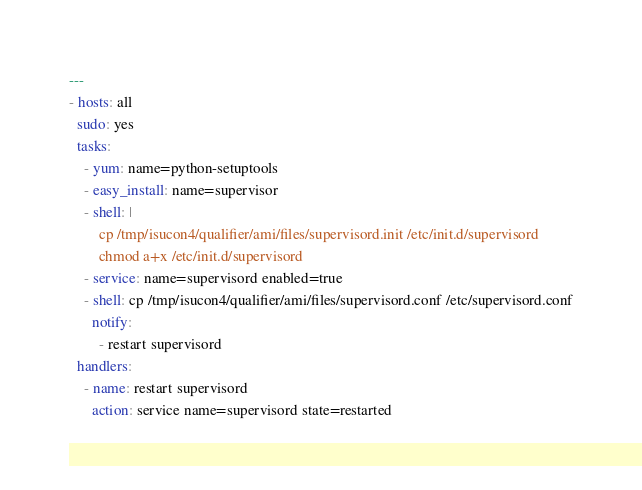Convert code to text. <code><loc_0><loc_0><loc_500><loc_500><_YAML_>---
- hosts: all
  sudo: yes
  tasks:
    - yum: name=python-setuptools
    - easy_install: name=supervisor
    - shell: |
        cp /tmp/isucon4/qualifier/ami/files/supervisord.init /etc/init.d/supervisord
        chmod a+x /etc/init.d/supervisord
    - service: name=supervisord enabled=true
    - shell: cp /tmp/isucon4/qualifier/ami/files/supervisord.conf /etc/supervisord.conf
      notify:
        - restart supervisord
  handlers:
    - name: restart supervisord
      action: service name=supervisord state=restarted
</code> 